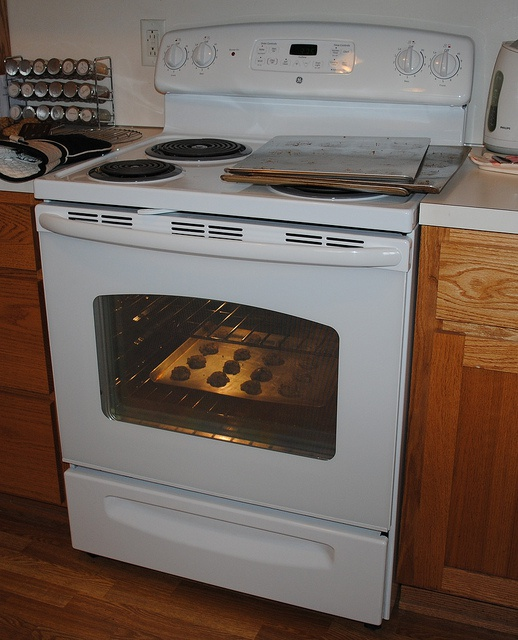Describe the objects in this image and their specific colors. I can see a oven in black, darkgray, and gray tones in this image. 